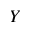<formula> <loc_0><loc_0><loc_500><loc_500>Y</formula> 